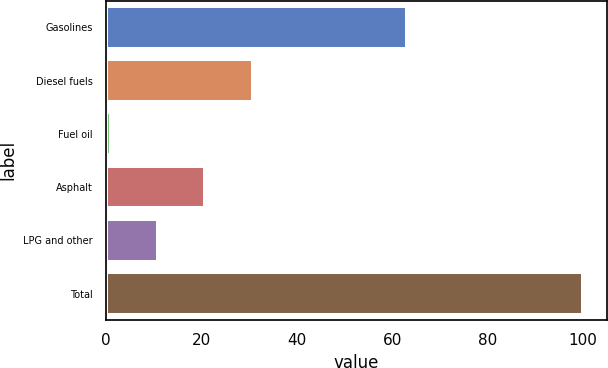Convert chart to OTSL. <chart><loc_0><loc_0><loc_500><loc_500><bar_chart><fcel>Gasolines<fcel>Diesel fuels<fcel>Fuel oil<fcel>Asphalt<fcel>LPG and other<fcel>Total<nl><fcel>63<fcel>30.7<fcel>1<fcel>20.8<fcel>10.9<fcel>100<nl></chart> 